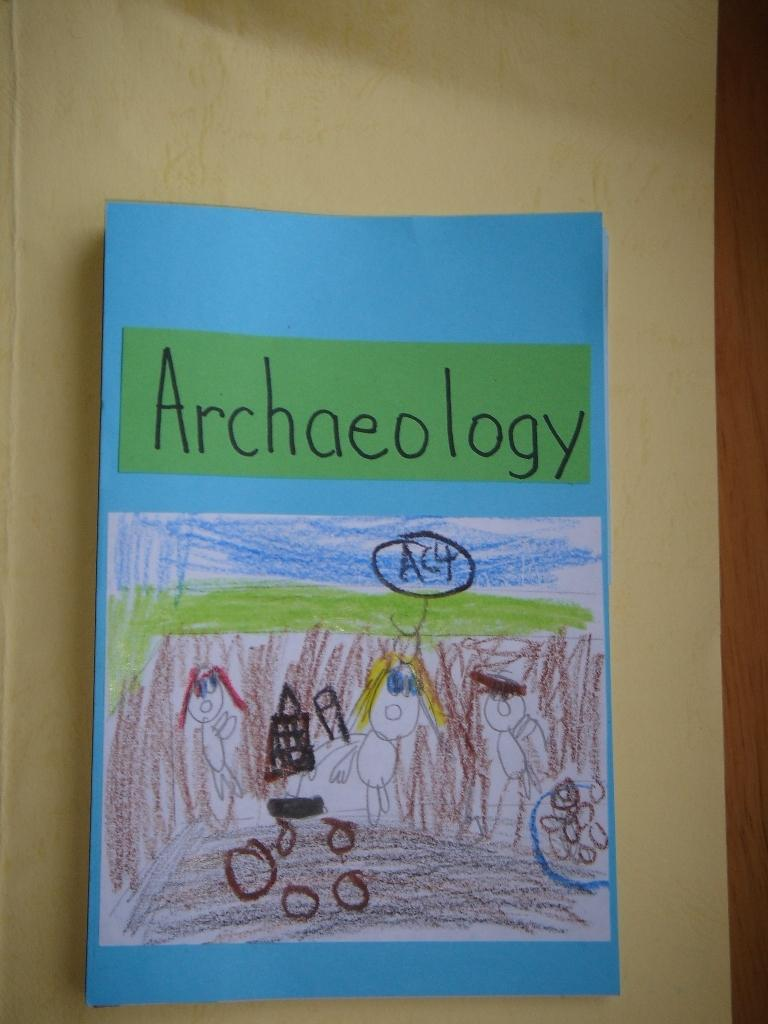<image>
Provide a brief description of the given image. A child's drawing about Archaeology hangs from the wall 